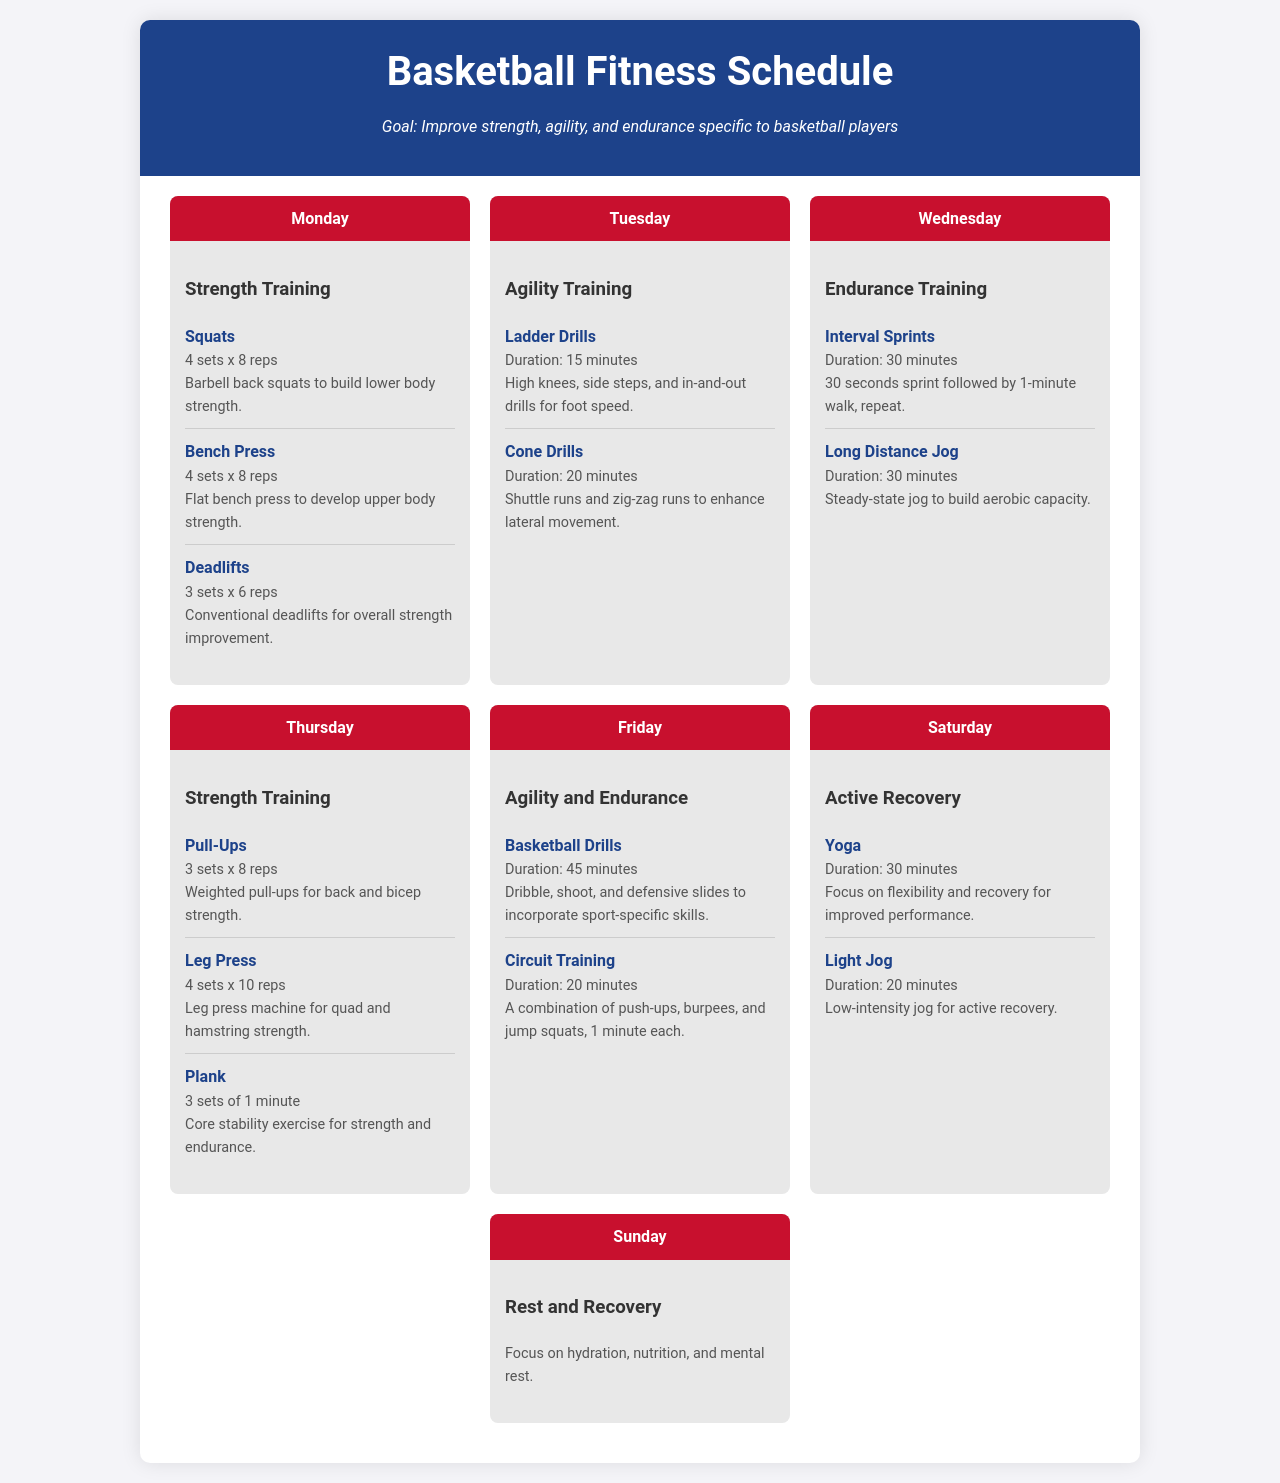What is the main goal of the schedule? The goal is stated in the header of the document, focusing on specific improvements for basketball players.
Answer: Improve strength, agility, and endurance specific to basketball players How many exercises are listed for Monday? The document details three exercises under the Monday section of the schedule.
Answer: 3 exercises What type of training is on Tuesday? The heading for Tuesday clearly indicates the focus of that day's training.
Answer: Agility Training What is the duration of the Interval Sprints? The duration of this exercise is specified in the Wednesday section of the schedule.
Answer: 30 minutes How many sets of Pull-Ups are recommended? This detail is provided in the Thursday section under strength training.
Answer: 3 sets Which day focuses on active recovery? The specific day dedicated to active recovery is highlighted in the schedule.
Answer: Saturday What type of exercise is suggested for Sunday? The Sunday section emphasizes a particular focus on overall relaxation and recovery.
Answer: Rest and Recovery What exercise follows the Ladder Drills on Tuesday? The subsequent exercise after Ladder Drills in the Tuesday schedule can be found in the same section.
Answer: Cone Drills What exercise is to be done for core stability on Thursday? This information can be located in the Thursday area's specific exercises dedicated to strength training.
Answer: Plank 